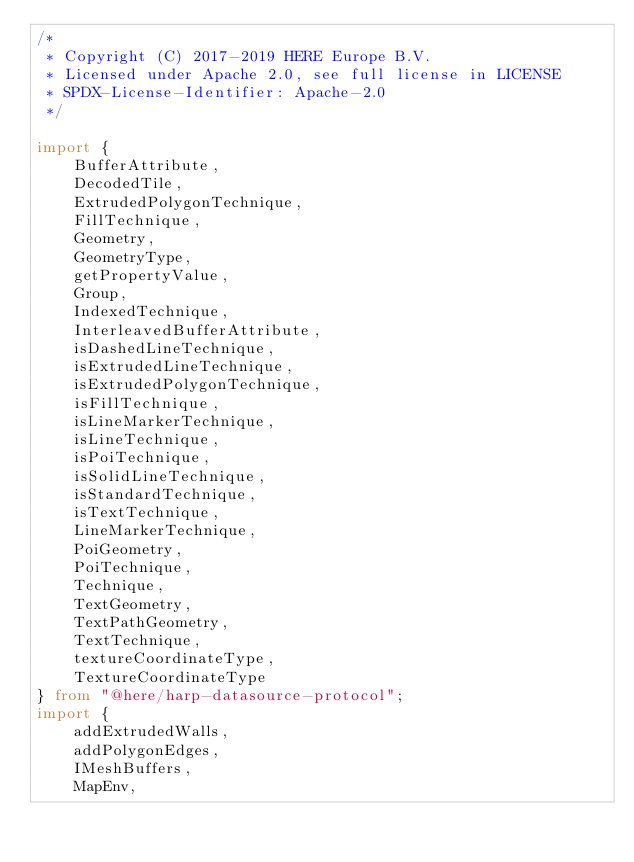Convert code to text. <code><loc_0><loc_0><loc_500><loc_500><_TypeScript_>/*
 * Copyright (C) 2017-2019 HERE Europe B.V.
 * Licensed under Apache 2.0, see full license in LICENSE
 * SPDX-License-Identifier: Apache-2.0
 */

import {
    BufferAttribute,
    DecodedTile,
    ExtrudedPolygonTechnique,
    FillTechnique,
    Geometry,
    GeometryType,
    getPropertyValue,
    Group,
    IndexedTechnique,
    InterleavedBufferAttribute,
    isDashedLineTechnique,
    isExtrudedLineTechnique,
    isExtrudedPolygonTechnique,
    isFillTechnique,
    isLineMarkerTechnique,
    isLineTechnique,
    isPoiTechnique,
    isSolidLineTechnique,
    isStandardTechnique,
    isTextTechnique,
    LineMarkerTechnique,
    PoiGeometry,
    PoiTechnique,
    Technique,
    TextGeometry,
    TextPathGeometry,
    TextTechnique,
    textureCoordinateType,
    TextureCoordinateType
} from "@here/harp-datasource-protocol";
import {
    addExtrudedWalls,
    addPolygonEdges,
    IMeshBuffers,
    MapEnv,</code> 